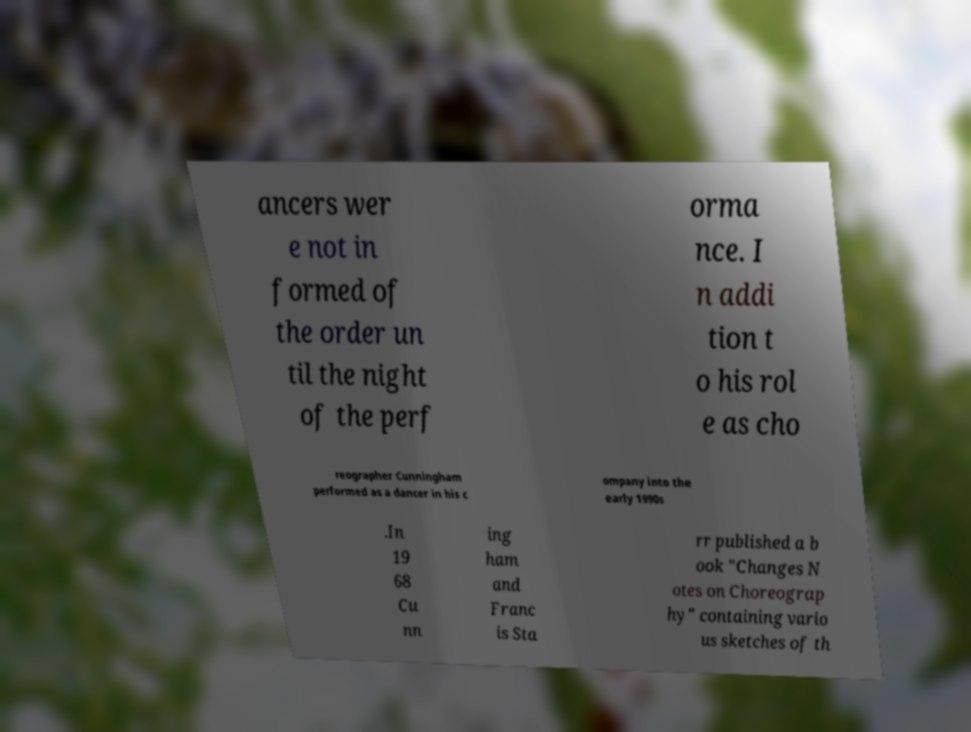Please identify and transcribe the text found in this image. ancers wer e not in formed of the order un til the night of the perf orma nce. I n addi tion t o his rol e as cho reographer Cunningham performed as a dancer in his c ompany into the early 1990s .In 19 68 Cu nn ing ham and Franc is Sta rr published a b ook "Changes N otes on Choreograp hy" containing vario us sketches of th 